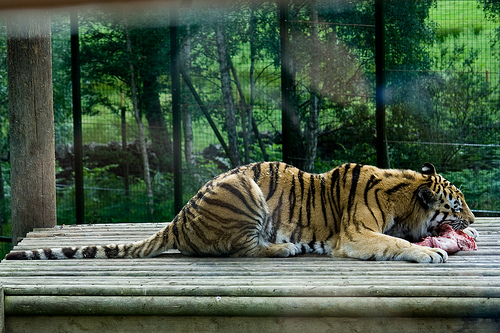<image>
Is the tree in front of the grate? No. The tree is not in front of the grate. The spatial positioning shows a different relationship between these objects. 